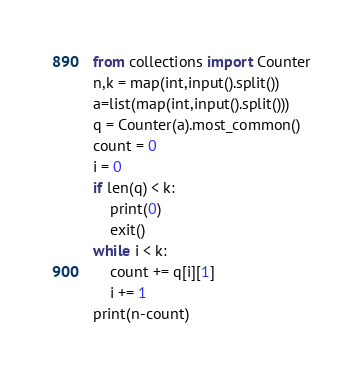<code> <loc_0><loc_0><loc_500><loc_500><_Python_>from collections import Counter
n,k = map(int,input().split())
a=list(map(int,input().split()))
q = Counter(a).most_common()
count = 0
i = 0
if len(q) < k:
    print(0)
    exit()
while i < k:
    count += q[i][1]
    i += 1
print(n-count)</code> 